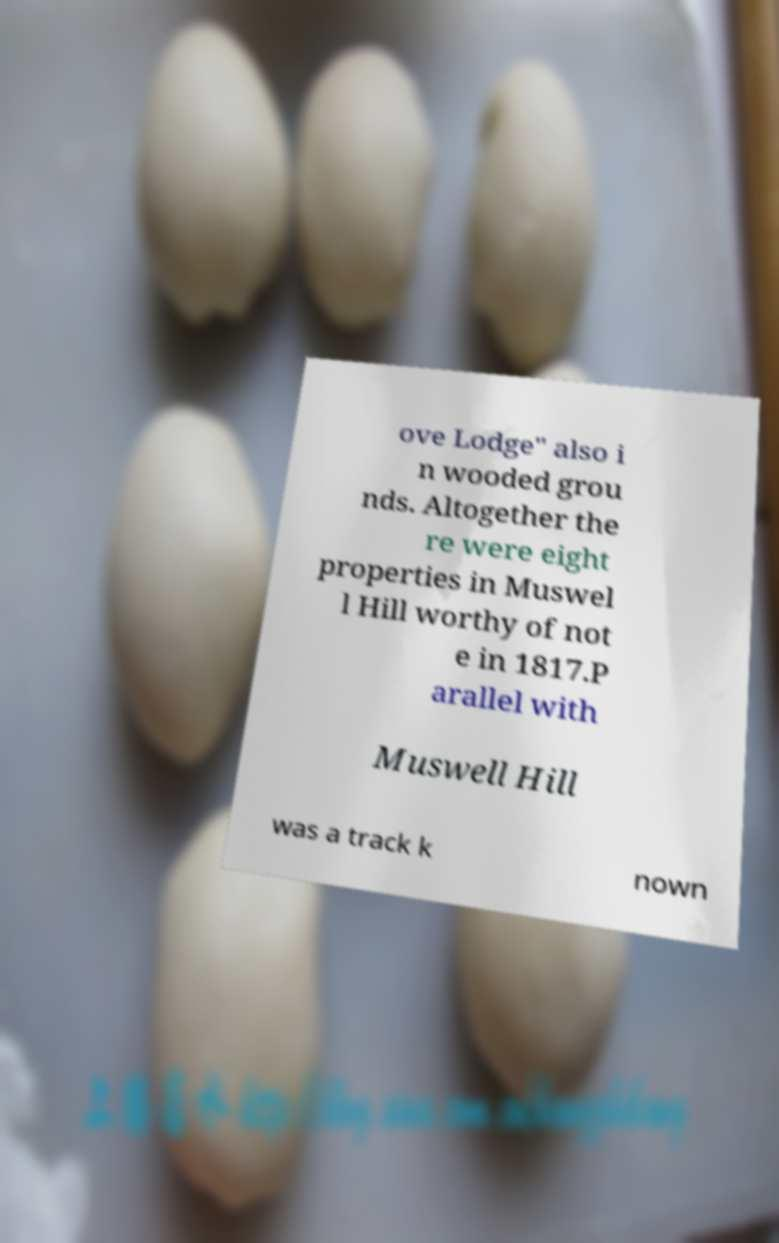Could you extract and type out the text from this image? ove Lodge" also i n wooded grou nds. Altogether the re were eight properties in Muswel l Hill worthy of not e in 1817.P arallel with Muswell Hill was a track k nown 